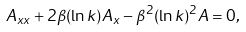<formula> <loc_0><loc_0><loc_500><loc_500>A _ { x x } + 2 \beta ( \ln k ) A _ { x } - \beta ^ { 2 } ( \ln k ) ^ { 2 } A = 0 ,</formula> 